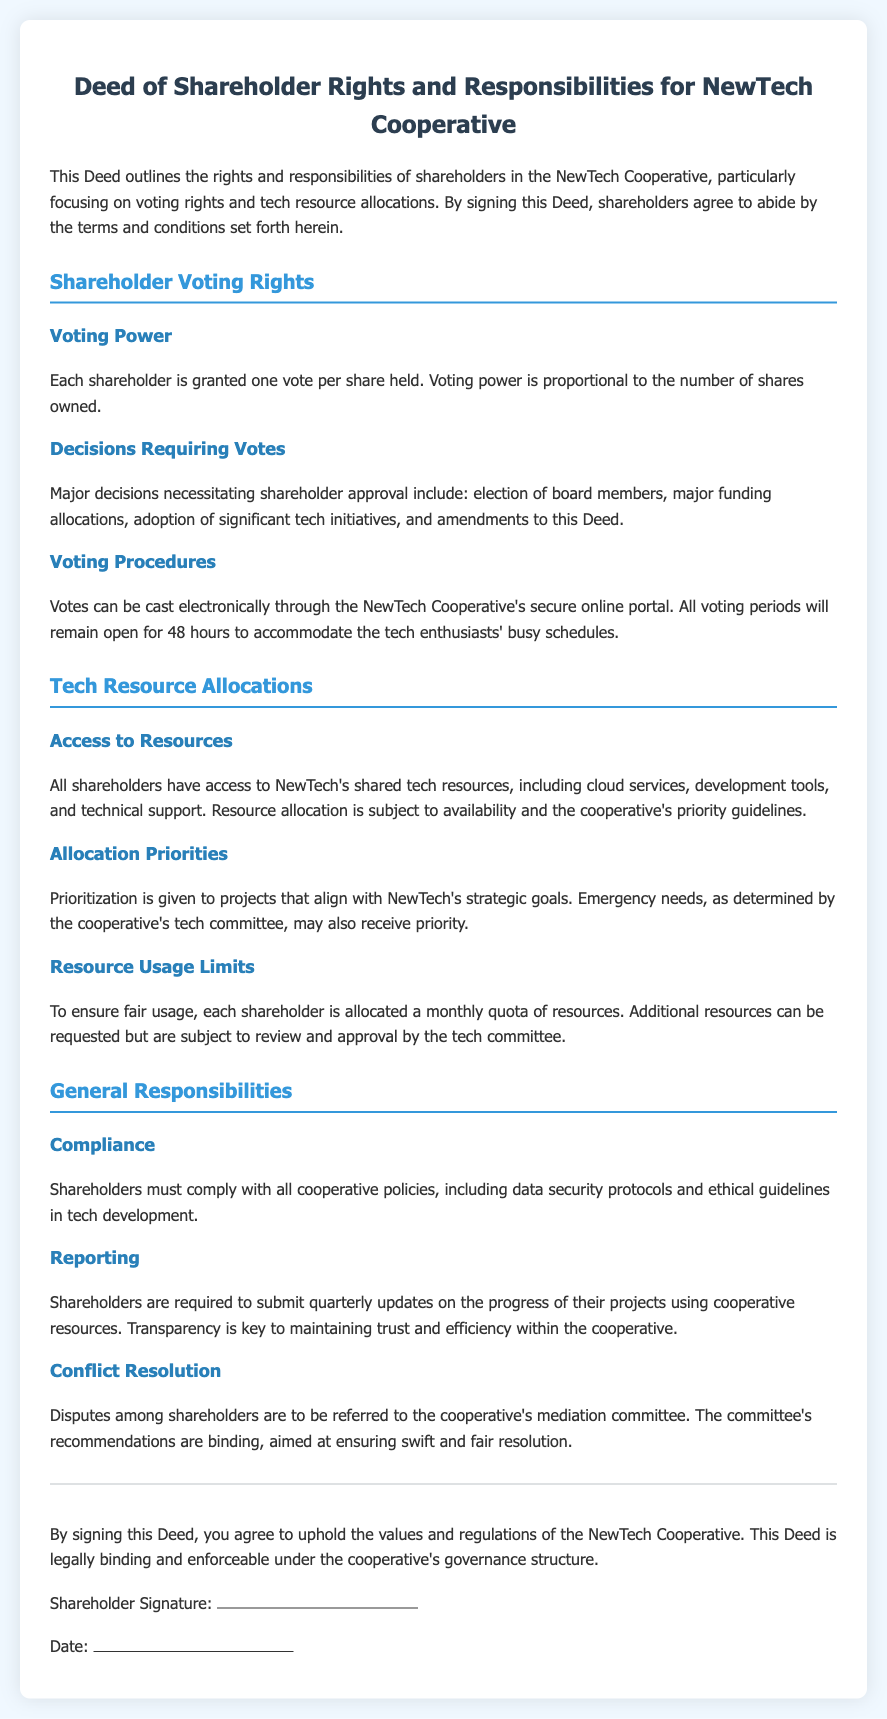What is the title of the document? The title provides the overarching theme and content of the document, which is about the rights and responsibilities of shareholders in a cooperative.
Answer: Deed of Shareholder Rights and Responsibilities for NewTech Cooperative How many votes does each shareholder have? This refers to the voting power granted to each shareholder, as stated in the document.
Answer: One vote per share What must shareholders do quarterly? This question pertains to the requirements set for shareholders regarding their project updates.
Answer: Submit quarterly updates What resource is mentioned as being shared among shareholders? This involves identifying specific resources that are accessible to all shareholders, outlined in the document.
Answer: Cloud services What is the priority of resource allocations based on? This question aims to understand the criteria for prioritizing resource distribution among the shareholders.
Answer: Strategic goals What committee handles conflict resolution among shareholders? This relates to the process of dispute management and the designated group to oversee it.
Answer: Mediation committee How long is the voting period open? This question seeks to clarify the duration allowed for shareholders to cast their votes.
Answer: 48 hours What must shareholders comply with according to the document? This question identifies the obligations shareholders agree to regarding cooperative operations.
Answer: Cooperative policies 